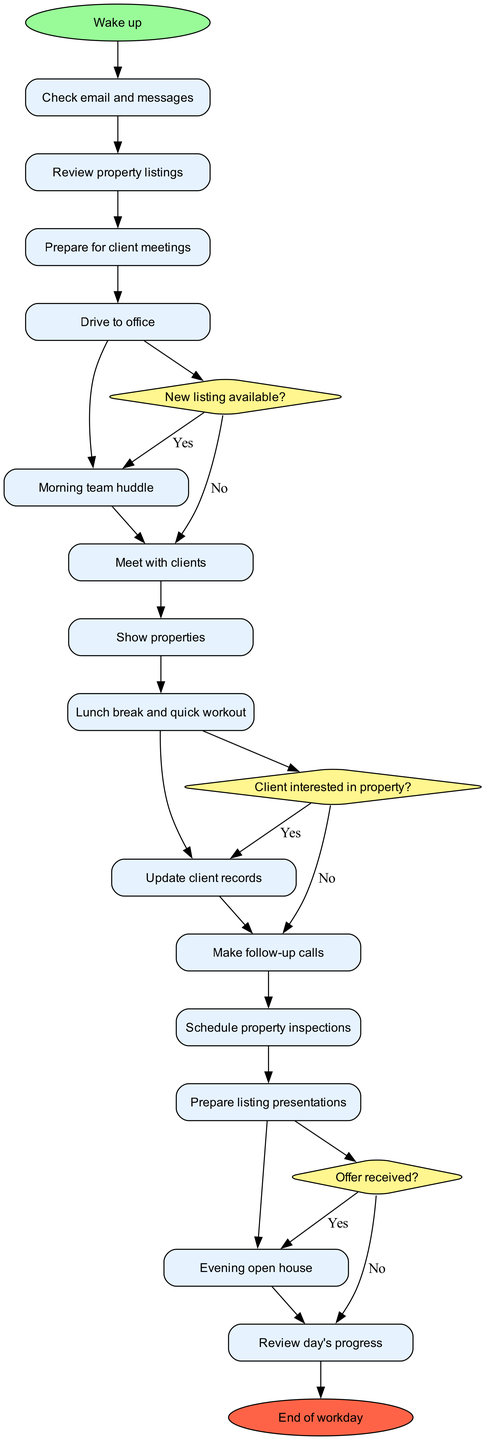What is the first activity listed in the diagram? The diagram begins with the node labeled "Wake up," which is the starting point of the daily routine. This is the first activity before any other tasks are performed.
Answer: Wake up How many activities are there in total? The diagram features a total of 14 activities, which encompass various tasks the real estate agent undertakes throughout the day, as listed in the activities section.
Answer: 14 What decision comes after "Update client records"? Following the activity "Update client records," the next decision node is "New listing available?" which decides the flow based on whether a new listing has been added.
Answer: New listing available? What happens if the decision "Client interested in property?" is answered with "No"? If the answer to "Client interested in property?" is "No," the flow moves to the next activity, which is "Prepare listing presentations," indicating that the agent will prepare presentations even if the client is not interested.
Answer: Prepare listing presentations What is the last activity before the end of the workday? The final activity before reaching the end of the workday is "Review day's progress," which allows the agent to evaluate what has been accomplished before concluding the day.
Answer: Review day's progress How many decisions are present in the diagram? There are three decision points in the diagram: "New listing available?", "Client interested in property?", and "Offer received?", assessing different conditions impacting the agent's workflow.
Answer: 3 What activity follows "Lunch break and quick workout"? After the "Lunch break and quick workout," the activity that follows is "Update client records," which indicates a return to administrative tasks post-lunch.
Answer: Update client records What activity is shown after "Meet with clients"? The next activity after "Meet with clients" is "Show properties," indicating a logical sequence in the agent's routine where client meetings are immediately followed by property showings.
Answer: Show properties If the agent receives an "Offer received?" as "Yes," what is the next step? If the decision "Offer received?" is answered with "Yes," the next activity is not explicitly indicated after the last decision in the diagram, suggesting that further actions or outcomes are required beyond the scope of this diagram.
Answer: N/A 